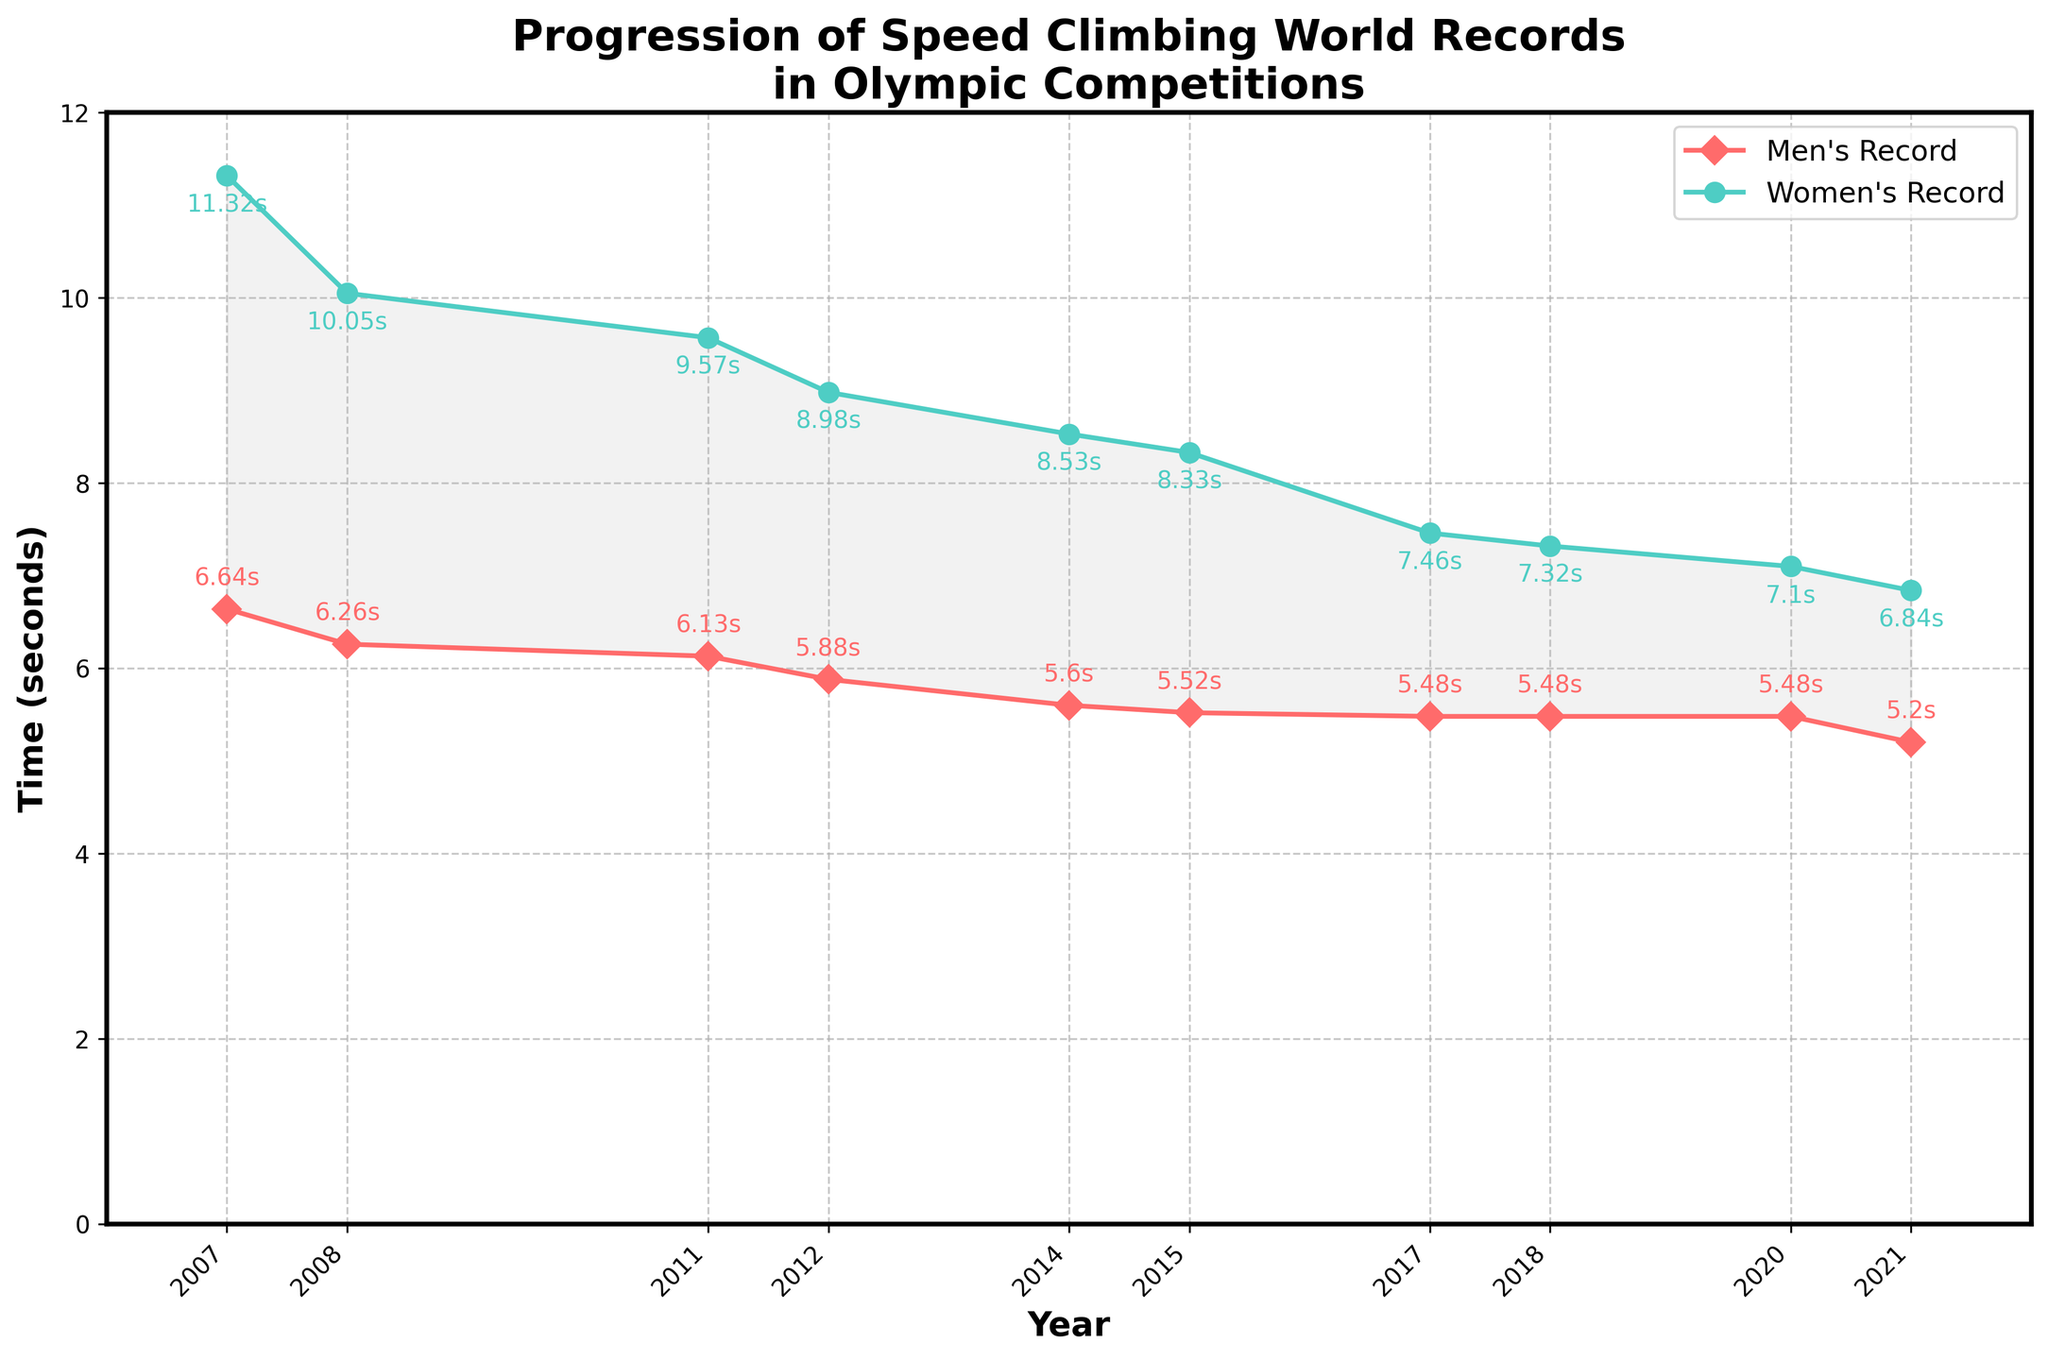How has the men's record changed from 2007 to 2021? In 2007, the men's record was 6.64 seconds. By 2021, it had improved to 5.20 seconds. This shows a decrease of 1.44 seconds over the period.
Answer: Decreased by 1.44 seconds Which year featured the largest drop in the women's record? The largest drop in the women's record occurred from 2018 (7.32 seconds) to 2020 (7.10 seconds), representing a decrease of 0.22 seconds.
Answer: 2020 By how many seconds did the women's record improve between 2017 and 2021? The women's record in 2017 was 7.46 seconds and improved to 6.84 seconds by 2021. This is an improvement of 0.62 seconds.
Answer: 0.62 seconds What can you say about the trend in the men's records over the years? The men's records show a consistent downward trend from 2007 to 2021, indicating that climbers have been getting faster over time.
Answer: Consistently decreasing How does the slope of the line for men's records compare to the slope of the line for women's records? Both slopes show a downward trend, but the women's line has steeper sections compared to the men's, showing more rapid improvements in certain periods.
Answer: Women's is steeper at times In which year did the men and women achieve the same amount of improvement, and what was that improvement? In 2018, both men and women did not improve their records, maintaining the same times as the previous year (2017).
Answer: 2018 (No improvement) During which years were the records for both men and women stable without any changes? For the men's records, the years were 2017, 2018, and 2020. For the women's records, it was stable in 2018.
Answer: Men's: 2017, 2018, 2020; Women's: 2018 What is the total improvement in seconds for both men's and women's records from 2007 to 2021? For men, the improvement is 6.64 to 5.20 seconds, a difference of 1.44 seconds. For women, the improvement is from 11.32 to 6.84 seconds, a difference of 4.48 seconds. The total improvement is 1.44 + 4.48 = 5.92 seconds.
Answer: 5.92 seconds 